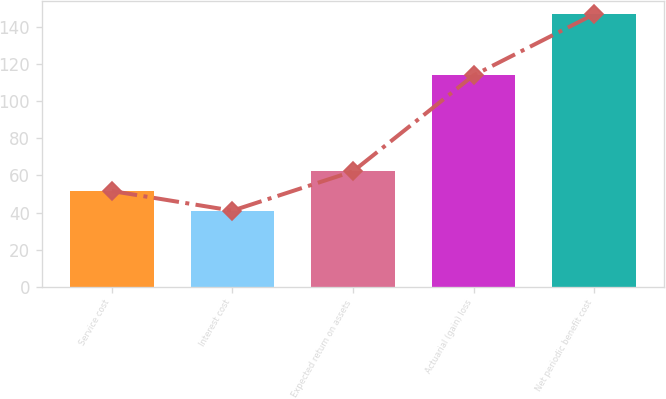Convert chart. <chart><loc_0><loc_0><loc_500><loc_500><bar_chart><fcel>Service cost<fcel>Interest cost<fcel>Expected return on assets<fcel>Actuarial (gain) loss<fcel>Net periodic benefit cost<nl><fcel>51.6<fcel>41<fcel>62.2<fcel>114<fcel>147<nl></chart> 